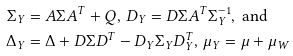<formula> <loc_0><loc_0><loc_500><loc_500>\Sigma _ { Y } & = A \Sigma A ^ { T } + Q , \, D _ { Y } = D \Sigma A ^ { T } \Sigma _ { Y } ^ { - 1 } , \text { and} \\ \Delta _ { Y } & = \Delta + D \Sigma D ^ { T } - D _ { Y } \Sigma _ { Y } D _ { Y } ^ { T } , \, \mu _ { Y } = \mu + \mu _ { W }</formula> 